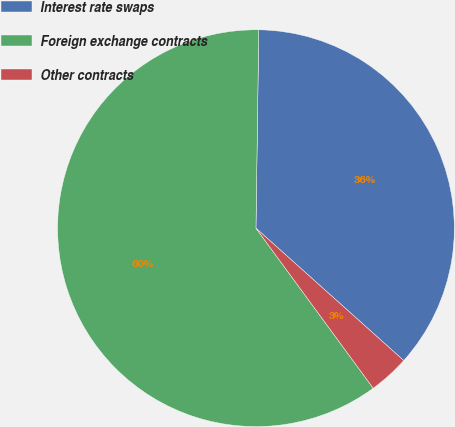Convert chart to OTSL. <chart><loc_0><loc_0><loc_500><loc_500><pie_chart><fcel>Interest rate swaps<fcel>Foreign exchange contracts<fcel>Other contracts<nl><fcel>36.4%<fcel>60.29%<fcel>3.31%<nl></chart> 